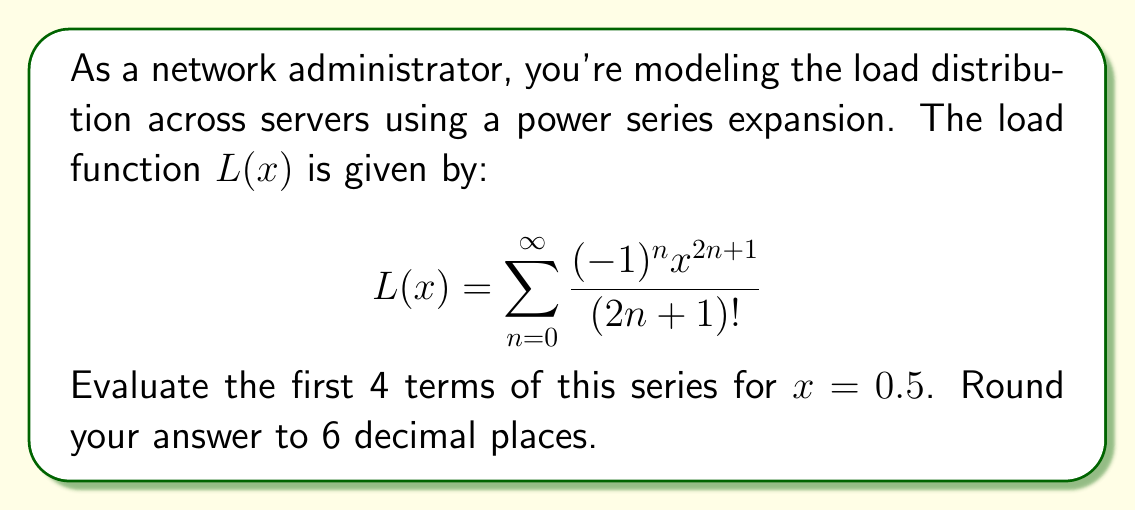Show me your answer to this math problem. Let's expand the series and calculate the first 4 terms:

1) For $n = 0$:
   $$\frac{(-1)^0 (0.5)^{2(0)+1}}{(2(0)+1)!} = \frac{0.5}{1!} = 0.5$$

2) For $n = 1$:
   $$\frac{(-1)^1 (0.5)^{2(1)+1}}{(2(1)+1)!} = -\frac{0.5^3}{3!} = -\frac{0.125}{6} = -0.020833$$

3) For $n = 2$:
   $$\frac{(-1)^2 (0.5)^{2(2)+1}}{(2(2)+1)!} = \frac{0.5^5}{5!} = \frac{0.03125}{120} = 0.000260$$

4) For $n = 3$:
   $$\frac{(-1)^3 (0.5)^{2(3)+1}}{(2(3)+1)!} = -\frac{0.5^7}{7!} = -\frac{0.0078125}{5040} = -0.000002$$

Now, sum these terms:

$$0.5 + (-0.020833) + 0.000260 + (-0.000002) = 0.479425$$

Rounding to 6 decimal places: 0.479425
Answer: 0.479425 